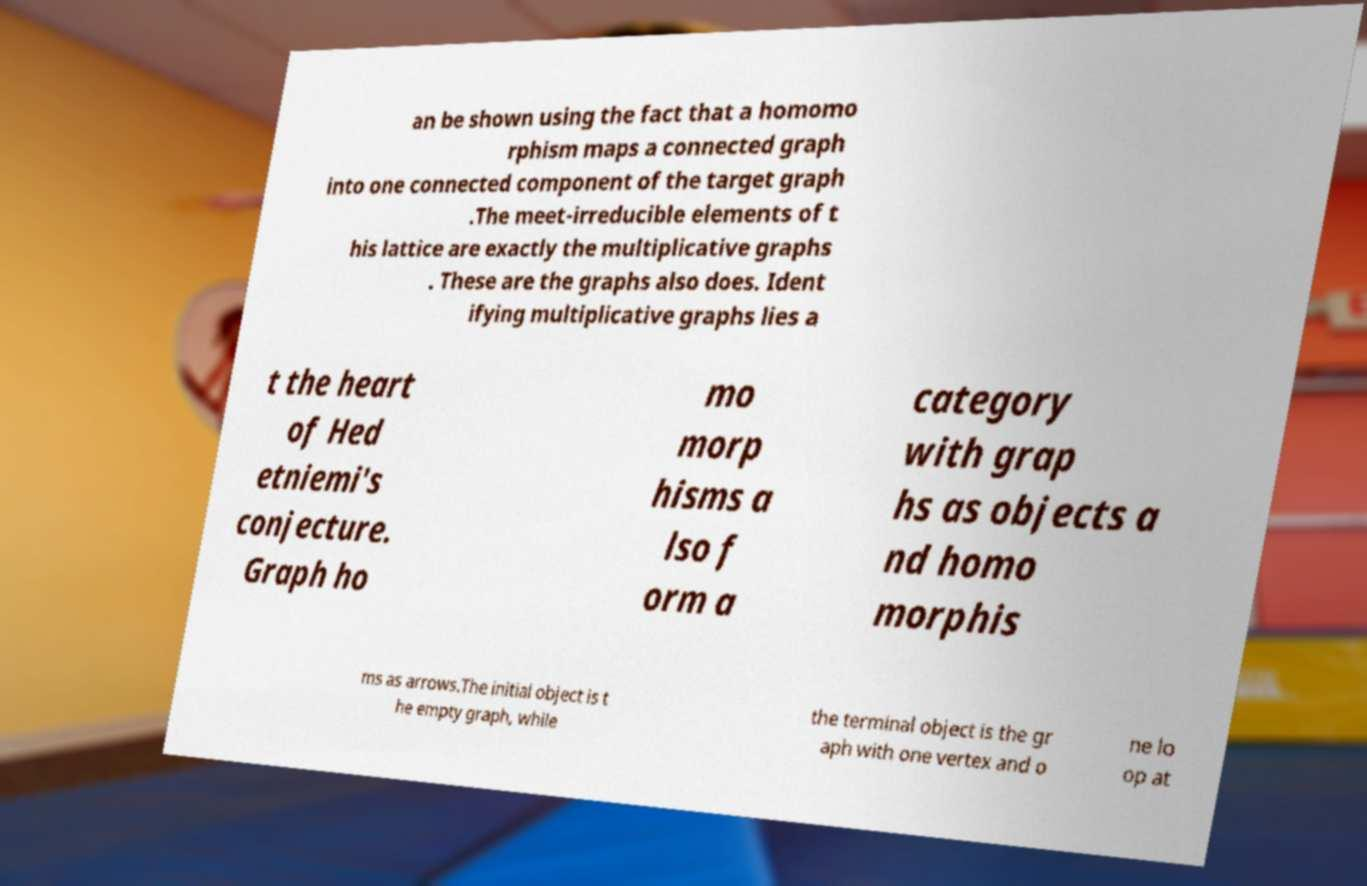Can you read and provide the text displayed in the image?This photo seems to have some interesting text. Can you extract and type it out for me? an be shown using the fact that a homomo rphism maps a connected graph into one connected component of the target graph .The meet-irreducible elements of t his lattice are exactly the multiplicative graphs . These are the graphs also does. Ident ifying multiplicative graphs lies a t the heart of Hed etniemi's conjecture. Graph ho mo morp hisms a lso f orm a category with grap hs as objects a nd homo morphis ms as arrows.The initial object is t he empty graph, while the terminal object is the gr aph with one vertex and o ne lo op at 